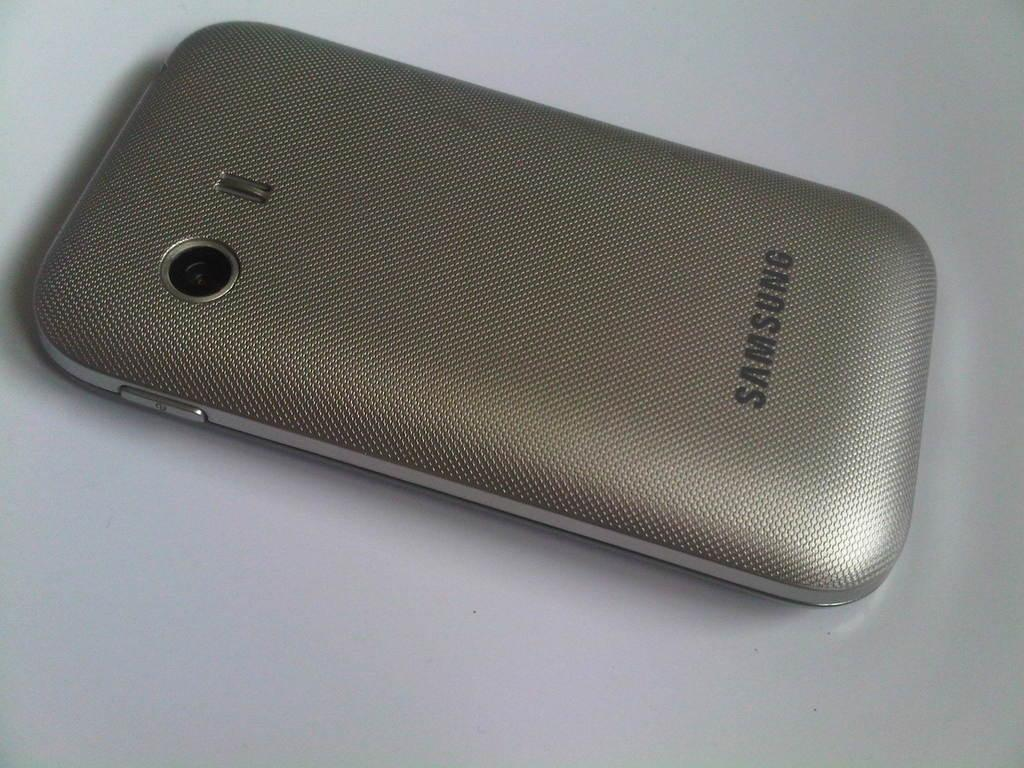Provide a one-sentence caption for the provided image. The back of a Samsung phone with the camera showing. 